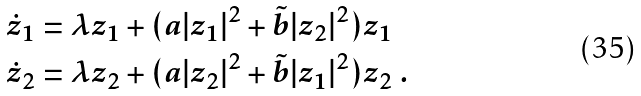<formula> <loc_0><loc_0><loc_500><loc_500>\dot { z } _ { 1 } & = \lambda z _ { 1 } + ( a | z _ { 1 } | ^ { 2 } + \tilde { b } | z _ { 2 } | ^ { 2 } ) z _ { 1 } \\ \dot { z } _ { 2 } & = \lambda z _ { 2 } + ( a | z _ { 2 } | ^ { 2 } + \tilde { b } | z _ { 1 } | ^ { 2 } ) z _ { 2 } \ .</formula> 